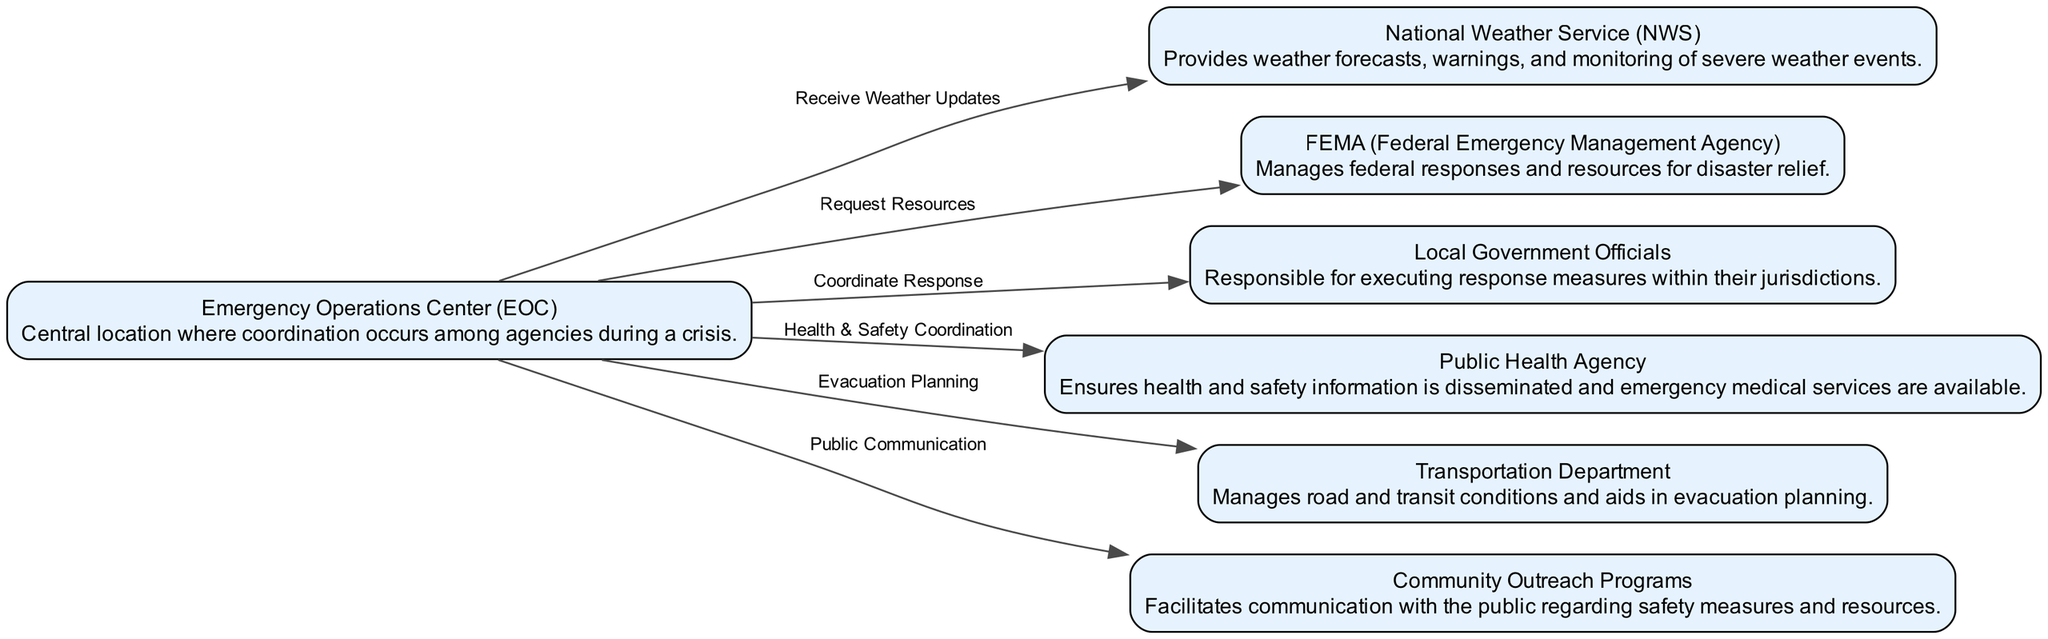What is the total number of nodes in the diagram? The diagram displays six distinct nodes, which represent the various agencies involved in the coordination during a severe weather event.
Answer: 7 Which agency provides weather forecasts and warnings? The National Weather Service (NWS) is specifically designated for providing weather forecasts, warnings, and monitoring of severe weather events.
Answer: National Weather Service (NWS) Who does the Emergency Operations Center request resources from? The Emergency Operations Center (EOC) is shown to request resources from FEMA (Federal Emergency Management Agency) in response to severe weather events.
Answer: FEMA (Federal Emergency Management Agency) What kind of coordination is there between the EOC and the Public Health Agency? The Emergency Operations Center (EOC) coordinates health and safety measures with the Public Health Agency to ensure that necessary information and services are provided during a severe weather event.
Answer: Health & Safety Coordination What role does the Transportation Department play in the event response? The Transportation Department is involved in evacuation planning as represented by the connection from the Emergency Operations Center (EOC) indicating their collaboration for managing transit and road conditions during a crisis.
Answer: Evacuation Planning Which agency handles public communication during the severe weather event? Community Outreach Programs are responsible for public communication during severe weather events, facilitating the dissemination of safety measures and resources.
Answer: Community Outreach Programs How many edges connect the Emergency Operations Center to other agencies? The Emergency Operations Center (EOC) has six edges connecting it to various agencies, indicating all the coordination efforts for the severe weather response displayed in the diagram.
Answer: 6 What is the flow direction of information from the EOC to local officials? The flow of information from the Emergency Operations Center to local government officials is visualized by an edge labeled 'Coordinate Response,' showing a direct line of communication and planning.
Answer: Coordinate Response Which agency is primarily tasked with ensuring emergency medical services are available? The Public Health Agency is the one primarily responsible for ensuring that emergency medical services are available during a severe weather event, as indicated in the coordination flow.
Answer: Public Health Agency 